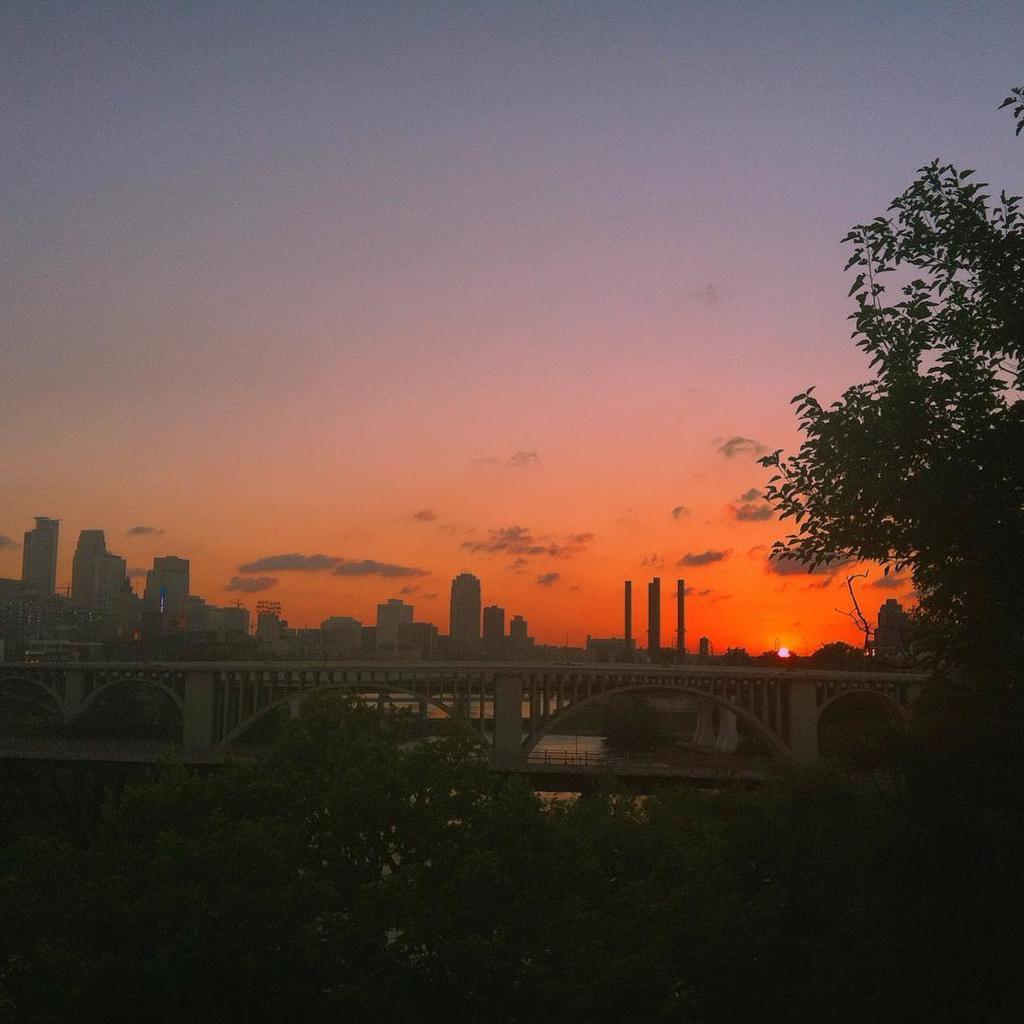In one or two sentences, can you explain what this image depicts? In this picture I can see a bridge, there is water, there are buildings, there are trees, and in the background there is the sky. 